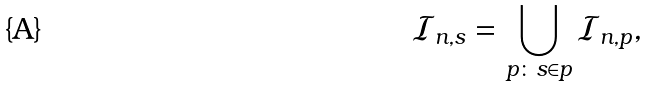<formula> <loc_0><loc_0><loc_500><loc_500>\mathcal { I } _ { n , s } = \bigcup _ { p \colon s \in p } \mathcal { I } _ { n , p } ,</formula> 